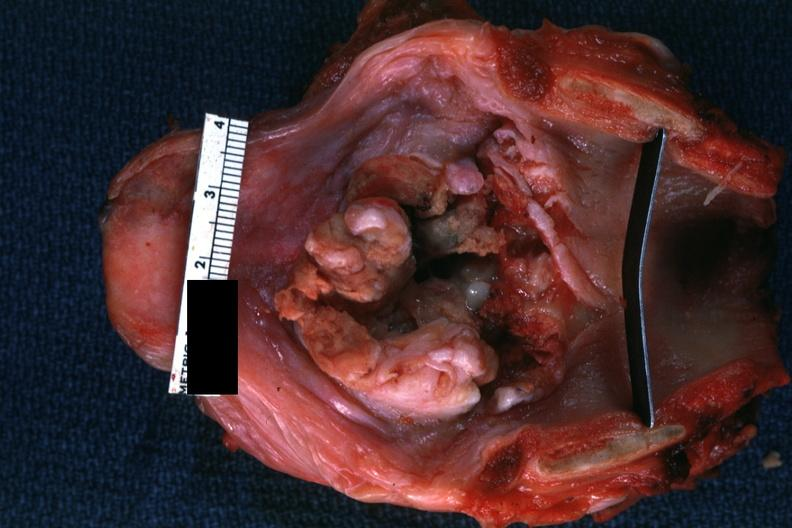s interesting case present?
Answer the question using a single word or phrase. No 